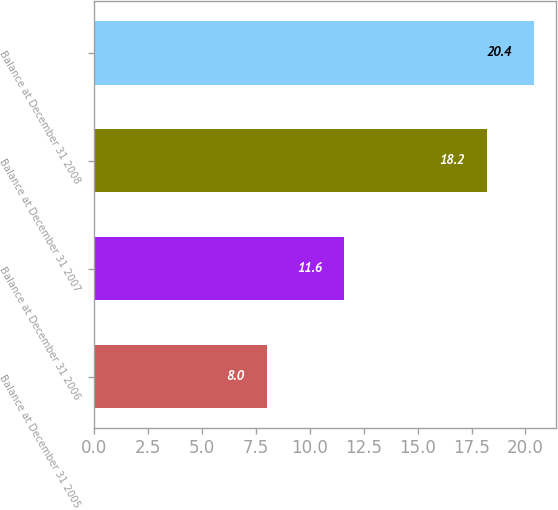Convert chart to OTSL. <chart><loc_0><loc_0><loc_500><loc_500><bar_chart><fcel>Balance at December 31 2005<fcel>Balance at December 31 2006<fcel>Balance at December 31 2007<fcel>Balance at December 31 2008<nl><fcel>8<fcel>11.6<fcel>18.2<fcel>20.4<nl></chart> 